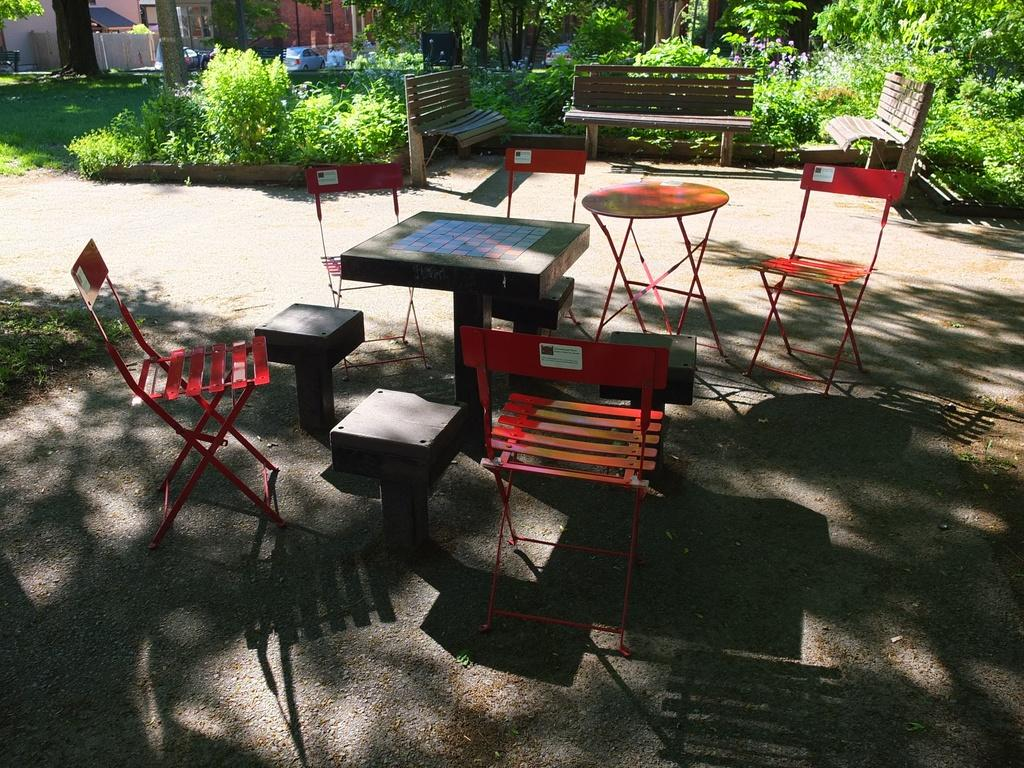What type of furniture is present in the image? There are tables, chairs, and benches in the image. What other objects can be seen in the image besides furniture? There are plants and shadows visible in the image. What type of vegetation is present in the image? There are plants in the image. What can be seen in the background of the image? There is grass visible in the background of the image. What letters are written on the benches in the image? There are no letters written on the benches in the image. What stage of development can be observed in the plants in the image? The provided facts do not give information about the development stage of the plants in the image. 